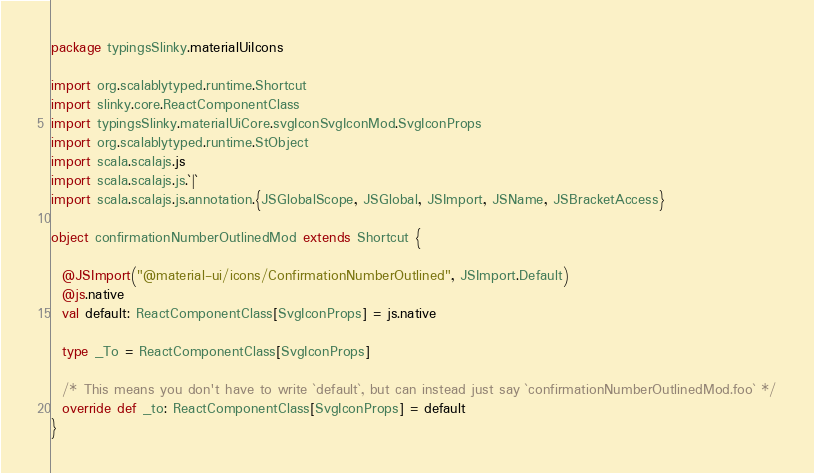<code> <loc_0><loc_0><loc_500><loc_500><_Scala_>package typingsSlinky.materialUiIcons

import org.scalablytyped.runtime.Shortcut
import slinky.core.ReactComponentClass
import typingsSlinky.materialUiCore.svgIconSvgIconMod.SvgIconProps
import org.scalablytyped.runtime.StObject
import scala.scalajs.js
import scala.scalajs.js.`|`
import scala.scalajs.js.annotation.{JSGlobalScope, JSGlobal, JSImport, JSName, JSBracketAccess}

object confirmationNumberOutlinedMod extends Shortcut {
  
  @JSImport("@material-ui/icons/ConfirmationNumberOutlined", JSImport.Default)
  @js.native
  val default: ReactComponentClass[SvgIconProps] = js.native
  
  type _To = ReactComponentClass[SvgIconProps]
  
  /* This means you don't have to write `default`, but can instead just say `confirmationNumberOutlinedMod.foo` */
  override def _to: ReactComponentClass[SvgIconProps] = default
}
</code> 